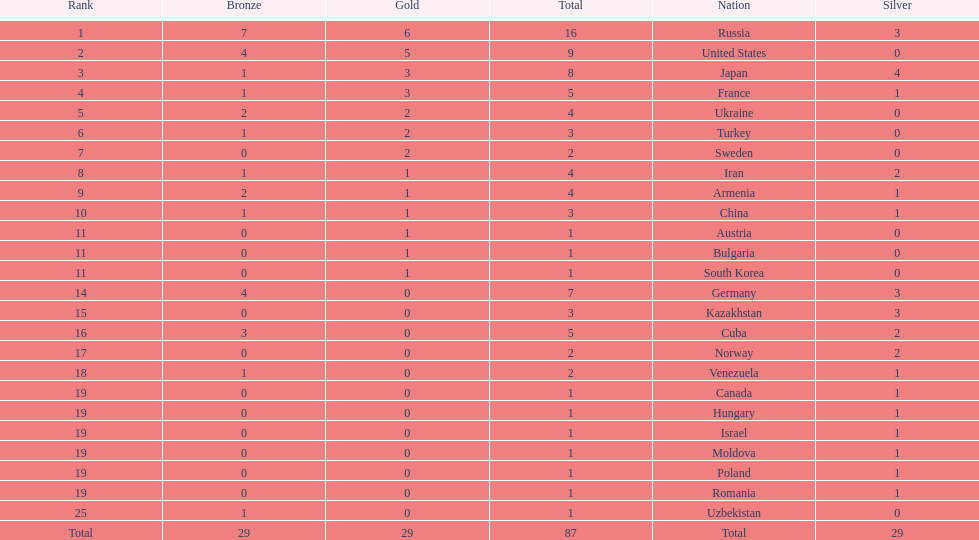Japan and france each won how many gold medals? 3. 